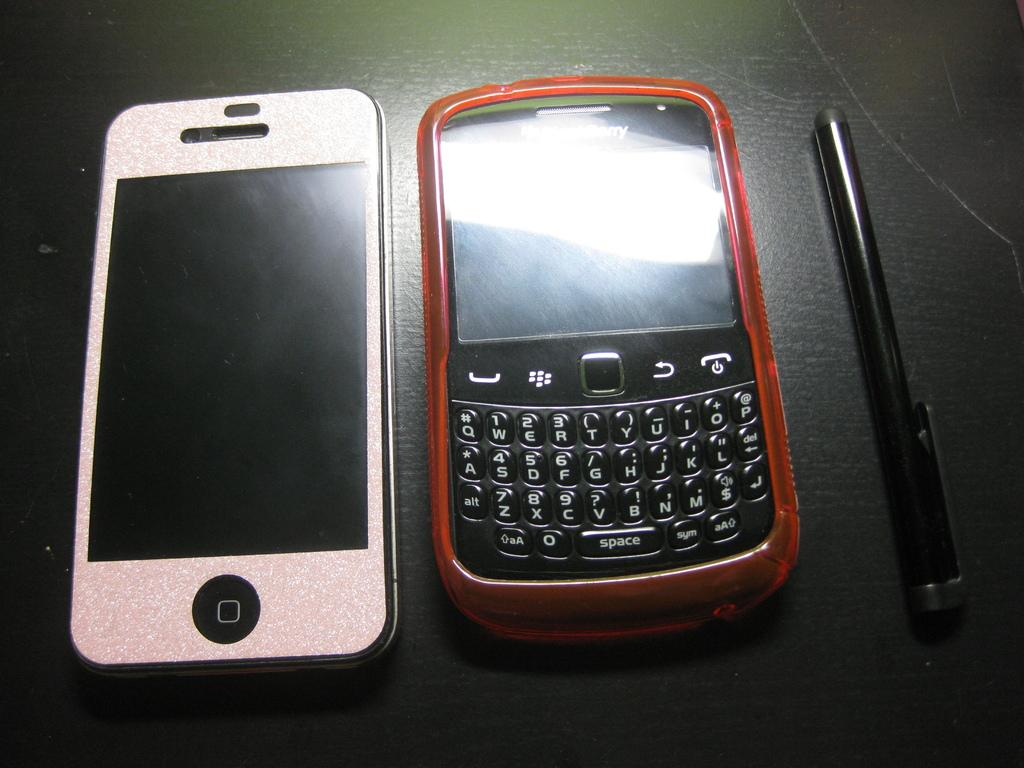Provide a one-sentence caption for the provided image. Two cell phones, one Iphone and one Blackberry on a table with a stylus. 